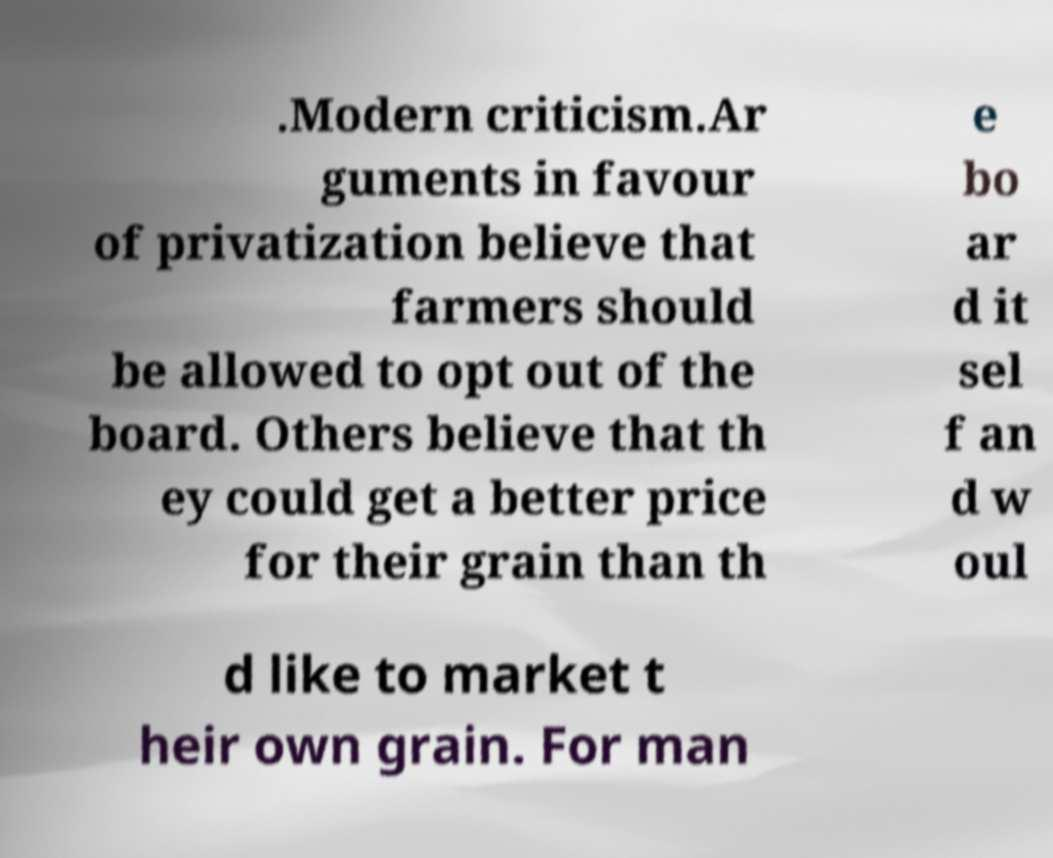Could you assist in decoding the text presented in this image and type it out clearly? .Modern criticism.Ar guments in favour of privatization believe that farmers should be allowed to opt out of the board. Others believe that th ey could get a better price for their grain than th e bo ar d it sel f an d w oul d like to market t heir own grain. For man 